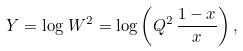<formula> <loc_0><loc_0><loc_500><loc_500>Y = \log \, W ^ { 2 } = \log \left ( Q ^ { 2 } \, \frac { 1 - x } { x } \right ) ,</formula> 